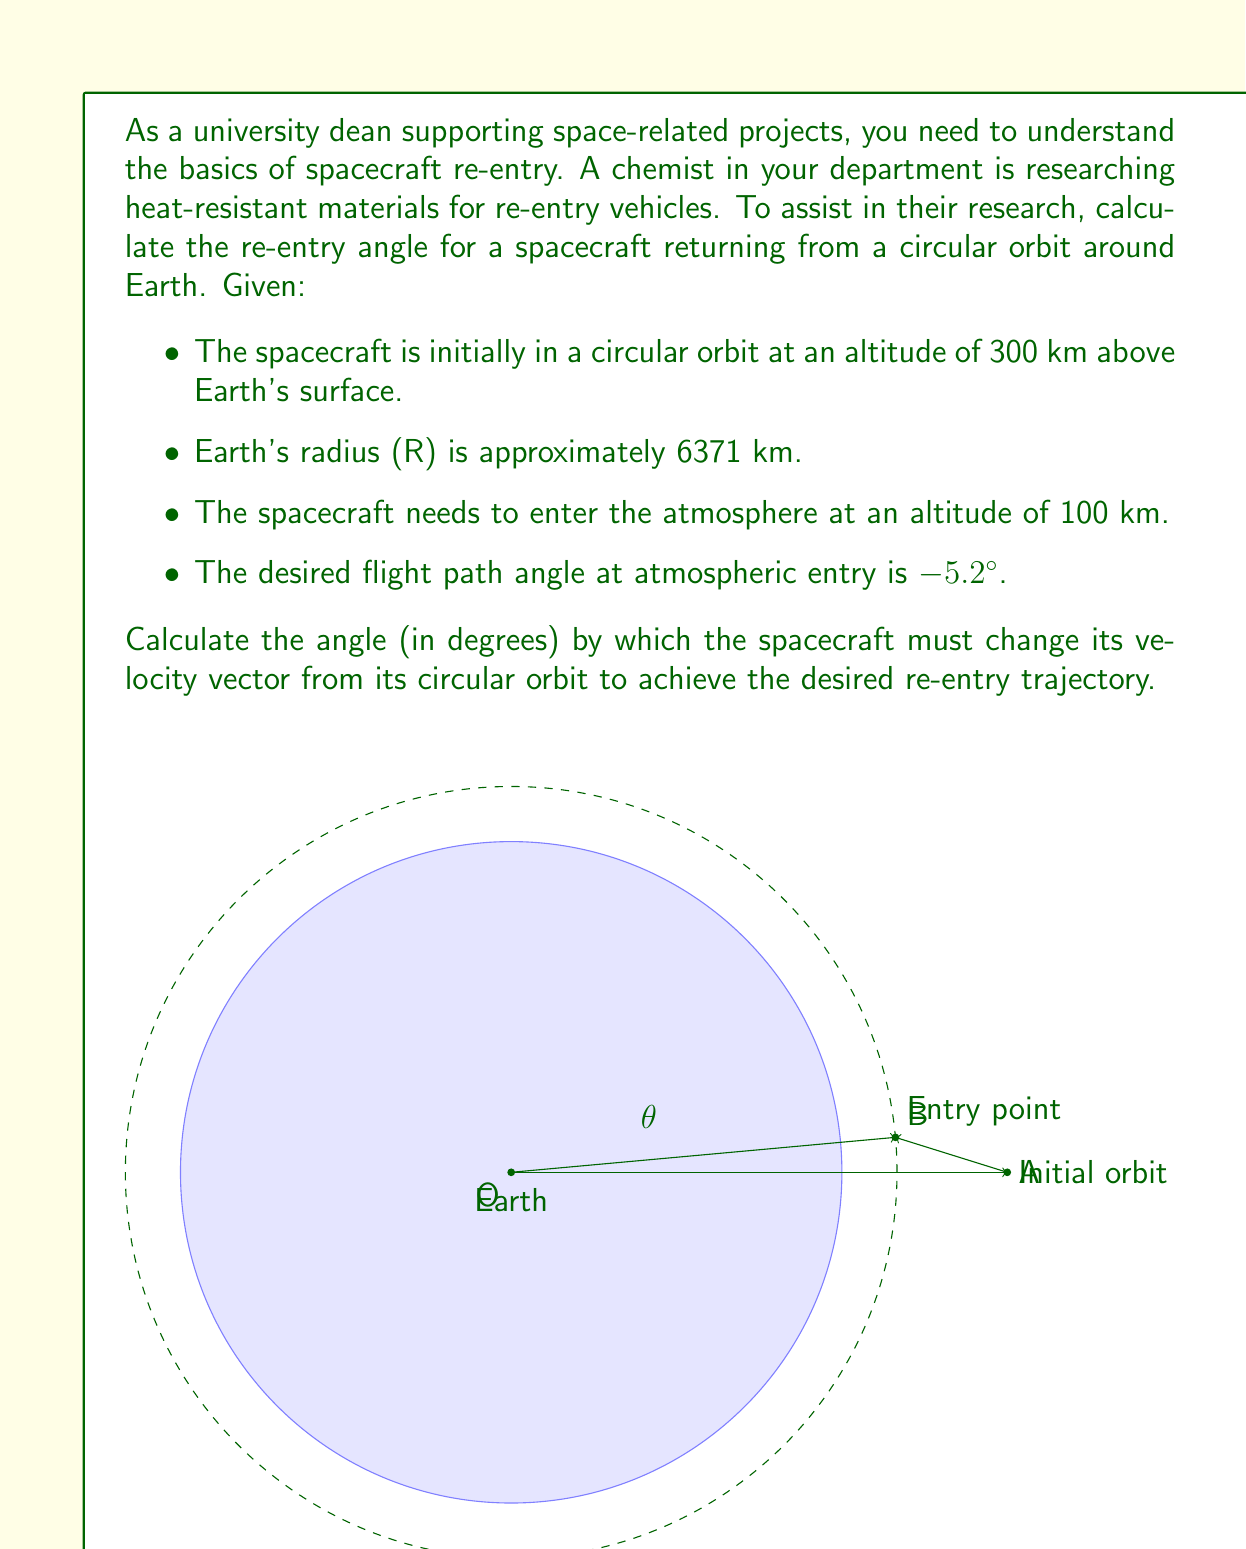Show me your answer to this math problem. To solve this problem, we'll use the principles of orbital mechanics and vector geometry. Let's break it down step-by-step:

1) First, let's define our variables:
   $R_E$ = Earth's radius = 6371 km
   $h_1$ = Initial orbit altitude = 300 km
   $h_2$ = Atmospheric entry altitude = 100 km
   $\gamma$ = Desired flight path angle at entry = -5.2°

2) The radius of the initial circular orbit:
   $r_1 = R_E + h_1 = 6371 + 300 = 6671$ km

3) The radius at atmospheric entry:
   $r_2 = R_E + h_2 = 6371 + 100 = 6471$ km

4) In a circular orbit, the velocity vector is perpendicular to the radius vector. The angle we're looking for ($\theta$) is the difference between this perpendicular direction and the direction of the velocity vector at atmospheric entry.

5) We can find this angle using the law of sines in the triangle formed by the center of Earth, the initial position, and the entry position:

   $$\frac{\sin(\theta)}{\sin(\gamma)} = \frac{r_2}{r_1}$$

6) Rearranging to solve for $\theta$:

   $$\theta = \arcsin(\frac{r_2}{r_1} \sin(\gamma))$$

7) Plugging in our values:

   $$\theta = \arcsin(\frac{6471}{6671} \sin(-5.2°))$$

8) Calculate:
   $$\theta \approx -5.04°$$

9) The negative sign indicates that the spacecraft needs to reduce its velocity in the direction of its orbit to enter the re-entry trajectory.
Answer: The spacecraft must change its velocity vector by approximately 5.04° to achieve the desired re-entry trajectory. 